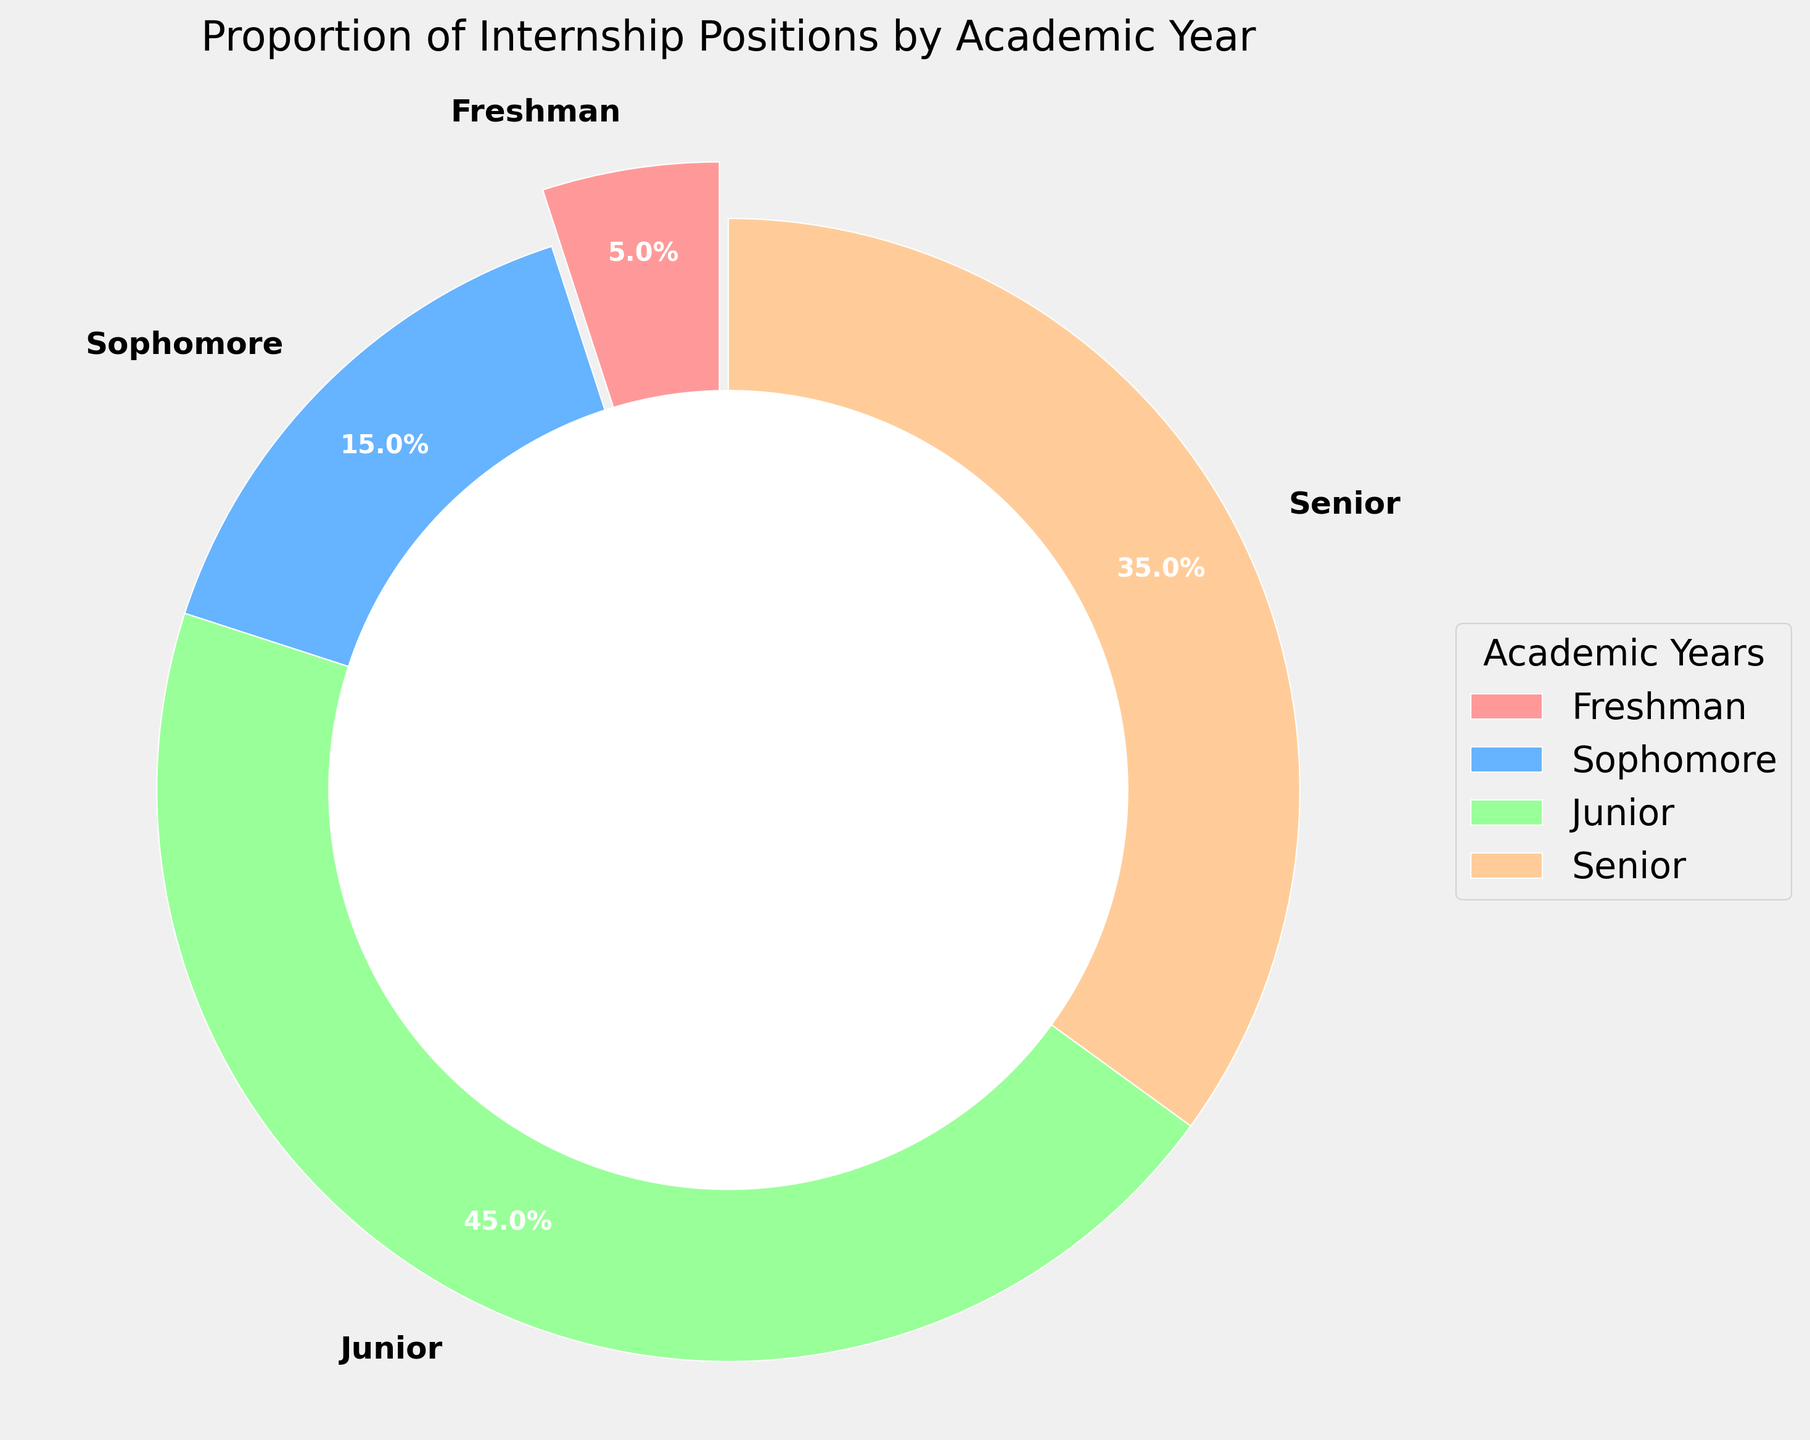what's the proportion of internship positions filled by juniors and seniors combined? The proportion of internship positions filled by juniors is 45%, and the proportion filled by seniors is 35%. Adding these two proportions together gives 45% + 35% = 80%.
Answer: 80% which academic year has the smallest proportion of internship positions? By visually comparing the sizes of the pie chart slices, the 'Freshman' slice has the smallest proportion at 5%.
Answer: Freshman are there more internship positions filled by sophomores or by seniors? By comparing the sizes of the pie chart slices, seniors fill 35% of internship positions, while sophomores fill 15%. Since 35% is greater than 15%, seniors fill more internship positions than sophomores.
Answer: Seniors how much greater is the proportion of internship positions filled by juniors compared to sophomores? The proportion of internship positions filled by juniors is 45%, and the proportion filled by sophomores is 15%. The difference between these proportions is 45% - 15% = 30%.
Answer: 30% what color represents the sophomore slice in the pie chart? The pie chart slices are given specific colors. By visually examining the pie chart, the sophomore slice is shown in blue.
Answer: Blue how does the proportion of internship positions filled by freshmen compare to that filled by seniors? By comparing the slices, freshmen fill 5% of positions, while seniors fill 35%. Thus, seniors fill a larger proportion of internship positions than freshmen.
Answer: Seniors fill more what proportion of internship positions is filled by underclassmen (freshmen and sophomores)? Freshmen fill 5% and sophomores fill 15%. Adding these percentages together, the total proportion filled by underclassmen is 5% + 15% = 20%.
Answer: 20% 